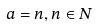Convert formula to latex. <formula><loc_0><loc_0><loc_500><loc_500>a = n , n \in N</formula> 